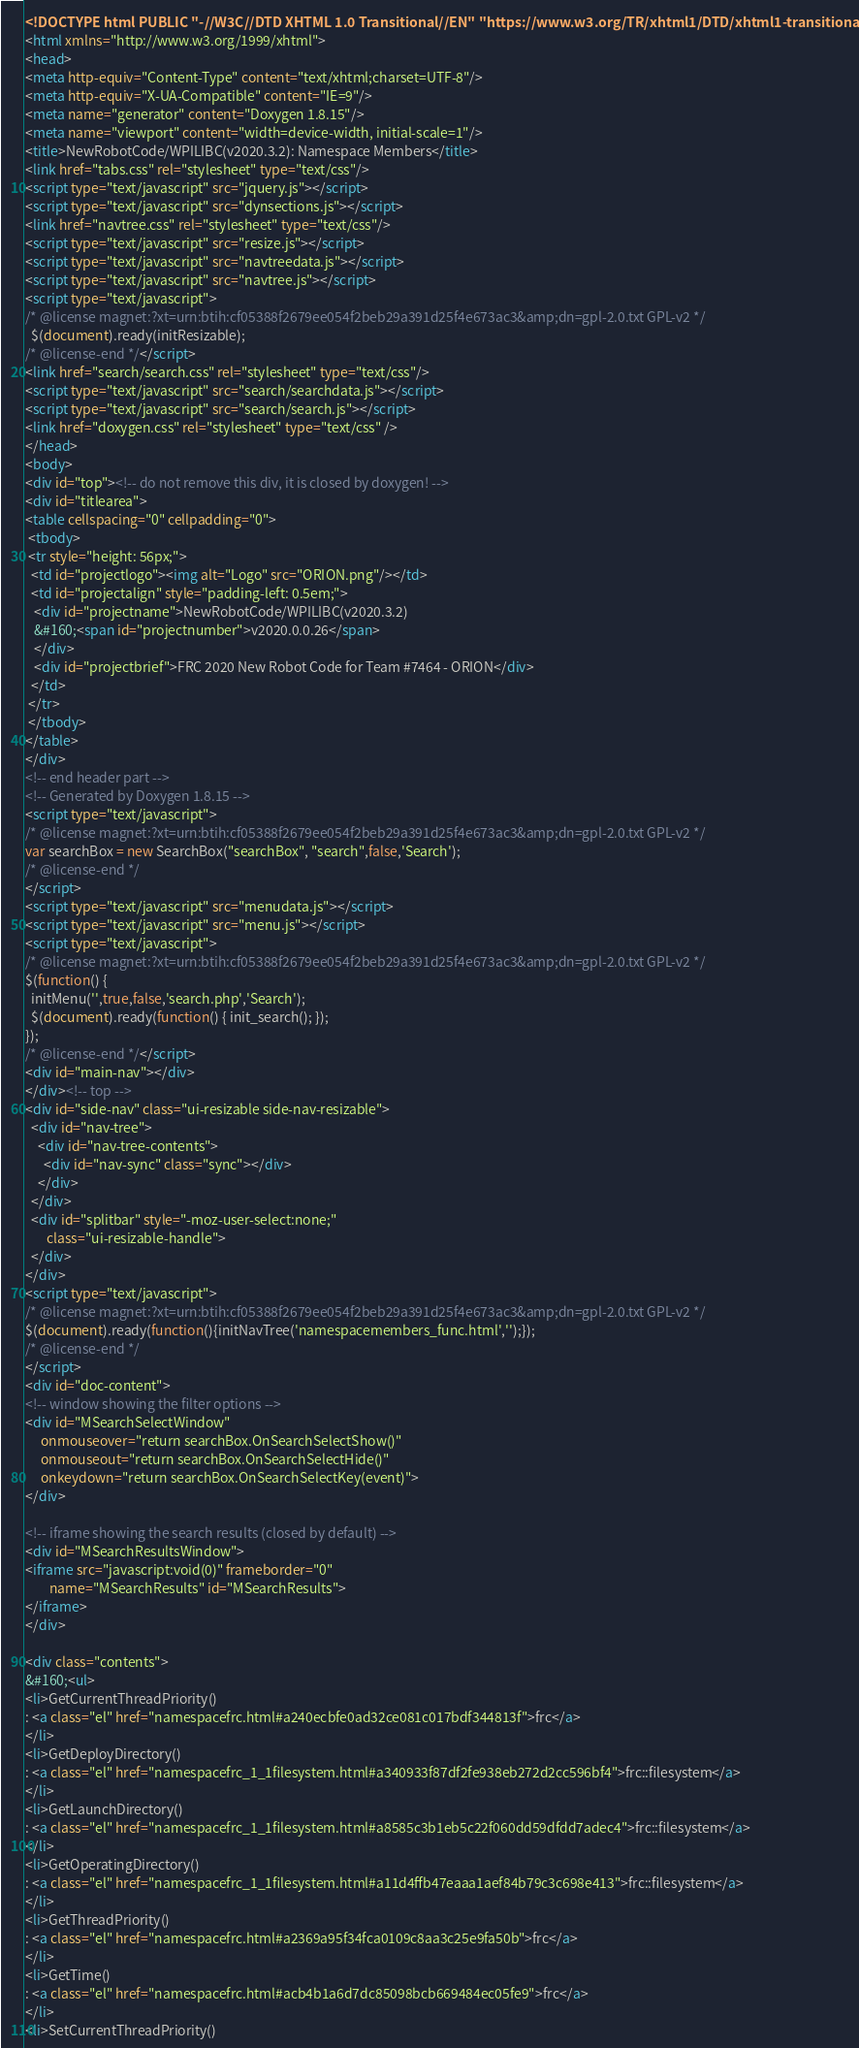<code> <loc_0><loc_0><loc_500><loc_500><_HTML_><!DOCTYPE html PUBLIC "-//W3C//DTD XHTML 1.0 Transitional//EN" "https://www.w3.org/TR/xhtml1/DTD/xhtml1-transitional.dtd">
<html xmlns="http://www.w3.org/1999/xhtml">
<head>
<meta http-equiv="Content-Type" content="text/xhtml;charset=UTF-8"/>
<meta http-equiv="X-UA-Compatible" content="IE=9"/>
<meta name="generator" content="Doxygen 1.8.15"/>
<meta name="viewport" content="width=device-width, initial-scale=1"/>
<title>NewRobotCode/WPILIBC(v2020.3.2): Namespace Members</title>
<link href="tabs.css" rel="stylesheet" type="text/css"/>
<script type="text/javascript" src="jquery.js"></script>
<script type="text/javascript" src="dynsections.js"></script>
<link href="navtree.css" rel="stylesheet" type="text/css"/>
<script type="text/javascript" src="resize.js"></script>
<script type="text/javascript" src="navtreedata.js"></script>
<script type="text/javascript" src="navtree.js"></script>
<script type="text/javascript">
/* @license magnet:?xt=urn:btih:cf05388f2679ee054f2beb29a391d25f4e673ac3&amp;dn=gpl-2.0.txt GPL-v2 */
  $(document).ready(initResizable);
/* @license-end */</script>
<link href="search/search.css" rel="stylesheet" type="text/css"/>
<script type="text/javascript" src="search/searchdata.js"></script>
<script type="text/javascript" src="search/search.js"></script>
<link href="doxygen.css" rel="stylesheet" type="text/css" />
</head>
<body>
<div id="top"><!-- do not remove this div, it is closed by doxygen! -->
<div id="titlearea">
<table cellspacing="0" cellpadding="0">
 <tbody>
 <tr style="height: 56px;">
  <td id="projectlogo"><img alt="Logo" src="ORION.png"/></td>
  <td id="projectalign" style="padding-left: 0.5em;">
   <div id="projectname">NewRobotCode/WPILIBC(v2020.3.2)
   &#160;<span id="projectnumber">v2020.0.0.26</span>
   </div>
   <div id="projectbrief">FRC 2020 New Robot Code for Team #7464 - ORION</div>
  </td>
 </tr>
 </tbody>
</table>
</div>
<!-- end header part -->
<!-- Generated by Doxygen 1.8.15 -->
<script type="text/javascript">
/* @license magnet:?xt=urn:btih:cf05388f2679ee054f2beb29a391d25f4e673ac3&amp;dn=gpl-2.0.txt GPL-v2 */
var searchBox = new SearchBox("searchBox", "search",false,'Search');
/* @license-end */
</script>
<script type="text/javascript" src="menudata.js"></script>
<script type="text/javascript" src="menu.js"></script>
<script type="text/javascript">
/* @license magnet:?xt=urn:btih:cf05388f2679ee054f2beb29a391d25f4e673ac3&amp;dn=gpl-2.0.txt GPL-v2 */
$(function() {
  initMenu('',true,false,'search.php','Search');
  $(document).ready(function() { init_search(); });
});
/* @license-end */</script>
<div id="main-nav"></div>
</div><!-- top -->
<div id="side-nav" class="ui-resizable side-nav-resizable">
  <div id="nav-tree">
    <div id="nav-tree-contents">
      <div id="nav-sync" class="sync"></div>
    </div>
  </div>
  <div id="splitbar" style="-moz-user-select:none;" 
       class="ui-resizable-handle">
  </div>
</div>
<script type="text/javascript">
/* @license magnet:?xt=urn:btih:cf05388f2679ee054f2beb29a391d25f4e673ac3&amp;dn=gpl-2.0.txt GPL-v2 */
$(document).ready(function(){initNavTree('namespacemembers_func.html','');});
/* @license-end */
</script>
<div id="doc-content">
<!-- window showing the filter options -->
<div id="MSearchSelectWindow"
     onmouseover="return searchBox.OnSearchSelectShow()"
     onmouseout="return searchBox.OnSearchSelectHide()"
     onkeydown="return searchBox.OnSearchSelectKey(event)">
</div>

<!-- iframe showing the search results (closed by default) -->
<div id="MSearchResultsWindow">
<iframe src="javascript:void(0)" frameborder="0" 
        name="MSearchResults" id="MSearchResults">
</iframe>
</div>

<div class="contents">
&#160;<ul>
<li>GetCurrentThreadPriority()
: <a class="el" href="namespacefrc.html#a240ecbfe0ad32ce081c017bdf344813f">frc</a>
</li>
<li>GetDeployDirectory()
: <a class="el" href="namespacefrc_1_1filesystem.html#a340933f87df2fe938eb272d2cc596bf4">frc::filesystem</a>
</li>
<li>GetLaunchDirectory()
: <a class="el" href="namespacefrc_1_1filesystem.html#a8585c3b1eb5c22f060dd59dfdd7adec4">frc::filesystem</a>
</li>
<li>GetOperatingDirectory()
: <a class="el" href="namespacefrc_1_1filesystem.html#a11d4ffb47eaaa1aef84b79c3c698e413">frc::filesystem</a>
</li>
<li>GetThreadPriority()
: <a class="el" href="namespacefrc.html#a2369a95f34fca0109c8aa3c25e9fa50b">frc</a>
</li>
<li>GetTime()
: <a class="el" href="namespacefrc.html#acb4b1a6d7dc85098bcb669484ec05fe9">frc</a>
</li>
<li>SetCurrentThreadPriority()</code> 